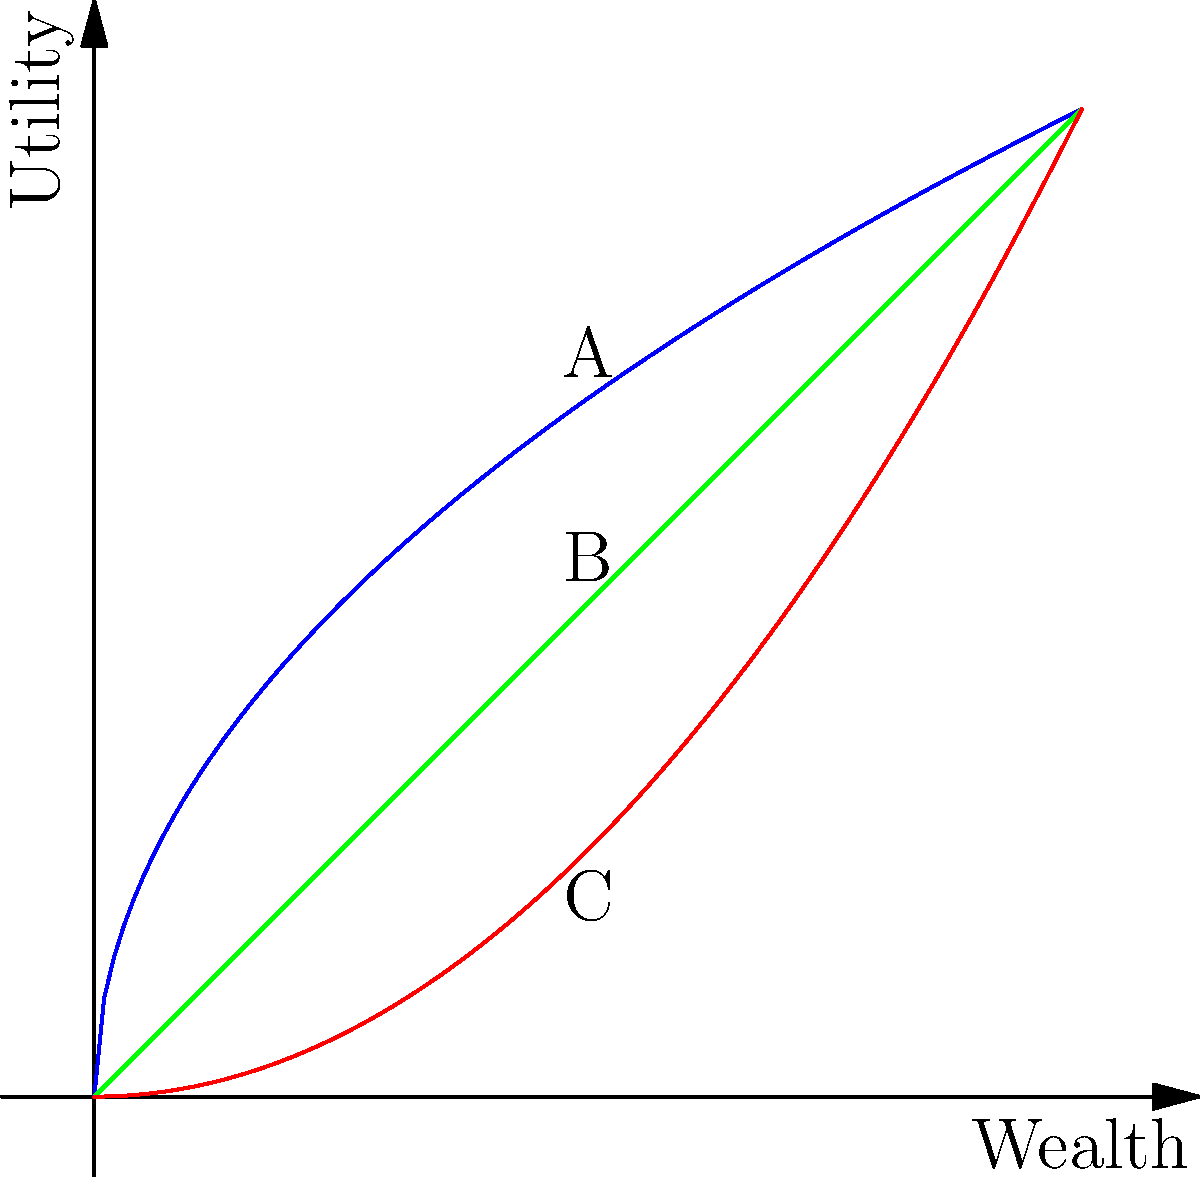Consider the utility curves shown in the graph above, representing different risk attitudes. A decision-maker is faced with two options:

1. A guaranteed gain of $500
2. A 50% chance of gaining $1000 and a 50% chance of gaining nothing

Which curve (A, B, or C) best represents the utility function of a decision-maker who would prefer the guaranteed $500 over the risky option? Explain your reasoning based on the properties of the curves and the concept of risk aversion. To answer this question, we need to understand the properties of each curve and how they relate to risk attitudes:

1. Curve A (blue) is concave, representing a risk-averse utility function.
2. Curve B (green) is linear, representing a risk-neutral utility function.
3. Curve C (red) is convex, representing a risk-seeking utility function.

A risk-averse decision-maker would prefer a guaranteed outcome over a risky option with the same expected value. Let's analyze the two options:

1. Guaranteed gain: $500
2. Risky option: 50% chance of $1000, 50% chance of $0
   Expected value = 0.5 * $1000 + 0.5 * $0 = $500

Both options have the same expected value of $500. However, a risk-averse individual would prefer the guaranteed $500 over the risky option.

Looking at the curves:
- Curve A (concave) shows that the utility gained from an increase in wealth diminishes as wealth increases. This property aligns with risk-averse behavior.
- Curve B (linear) represents risk-neutral behavior, where the utility is directly proportional to wealth.
- Curve C (convex) shows increasing utility gains as wealth increases, representing risk-seeking behavior.

Therefore, Curve A best represents the utility function of a decision-maker who would prefer the guaranteed $500 over the risky option, as it demonstrates risk-averse behavior.
Answer: Curve A (risk-averse) 